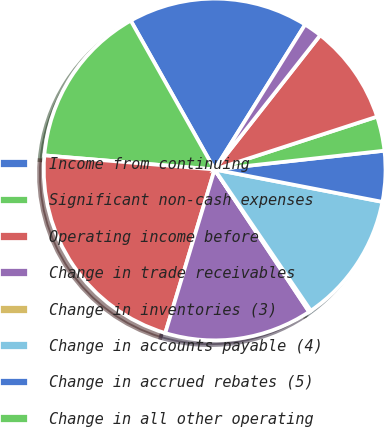Convert chart. <chart><loc_0><loc_0><loc_500><loc_500><pie_chart><fcel>Income from continuing<fcel>Significant non-cash expenses<fcel>Operating income before<fcel>Change in trade receivables<fcel>Change in inventories (3)<fcel>Change in accounts payable (4)<fcel>Change in accrued rebates (5)<fcel>Change in all other operating<fcel>Restructuring and other<fcel>Environmental spending<nl><fcel>17.05%<fcel>15.52%<fcel>21.65%<fcel>13.99%<fcel>0.19%<fcel>12.45%<fcel>4.79%<fcel>3.25%<fcel>9.39%<fcel>1.72%<nl></chart> 